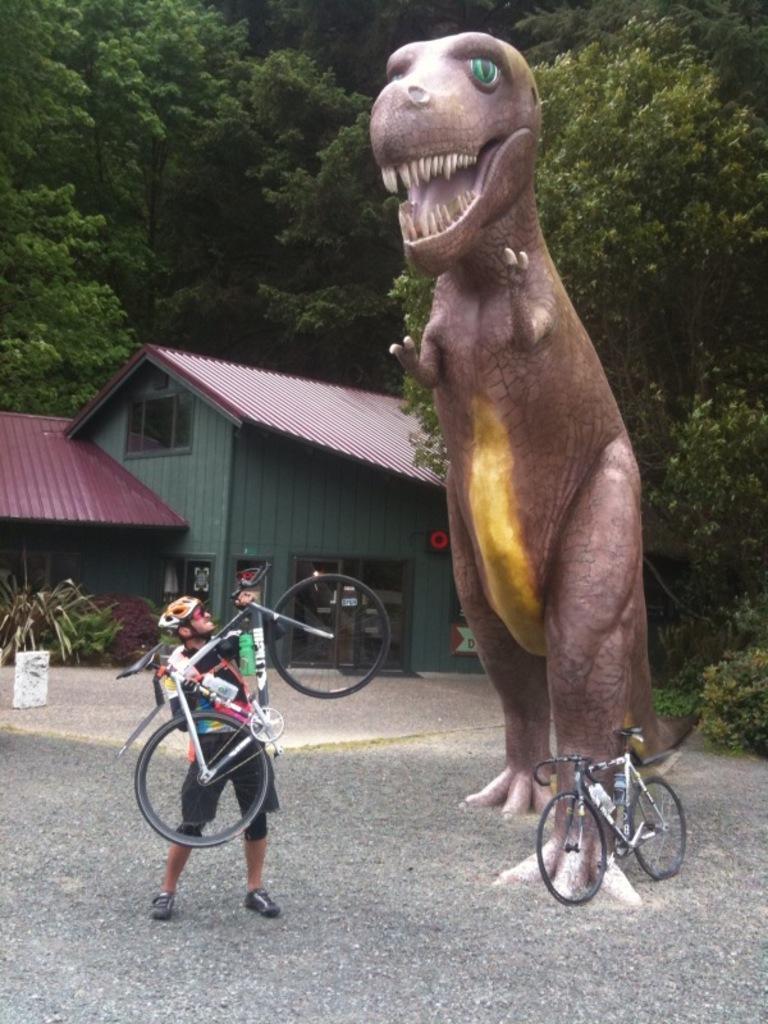Could you give a brief overview of what you see in this image? In this image we can see a statue and there is a person holding a bicycle, there are some trees, plants, windows and a house, also we can see a bicycle on the ground. 